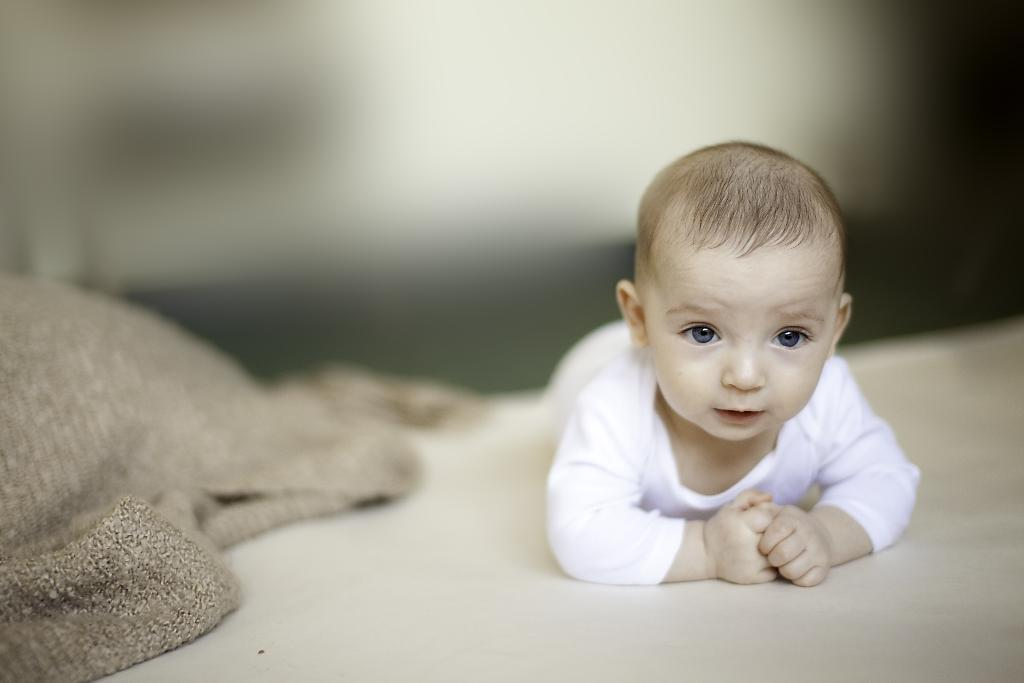What is the main subject of the image? There is a baby in the image. What is the baby wearing? The baby is wearing a white T-shirt. What is the baby doing in the image? The baby is looking at the camera. Can you describe the setting where the baby is located? The baby might be on a bed, and there is a blanket on the left side of the image. How would you describe the background of the image? The background of the image is blurred. What type of lunch is the baby eating in the image? There is no lunch present in the image; the baby is wearing a white T-shirt and looking at the camera. Can you see a beetle crawling on the baby's head in the image? There is no beetle present in the image; the baby is wearing a white T-shirt and looking at the camera. 